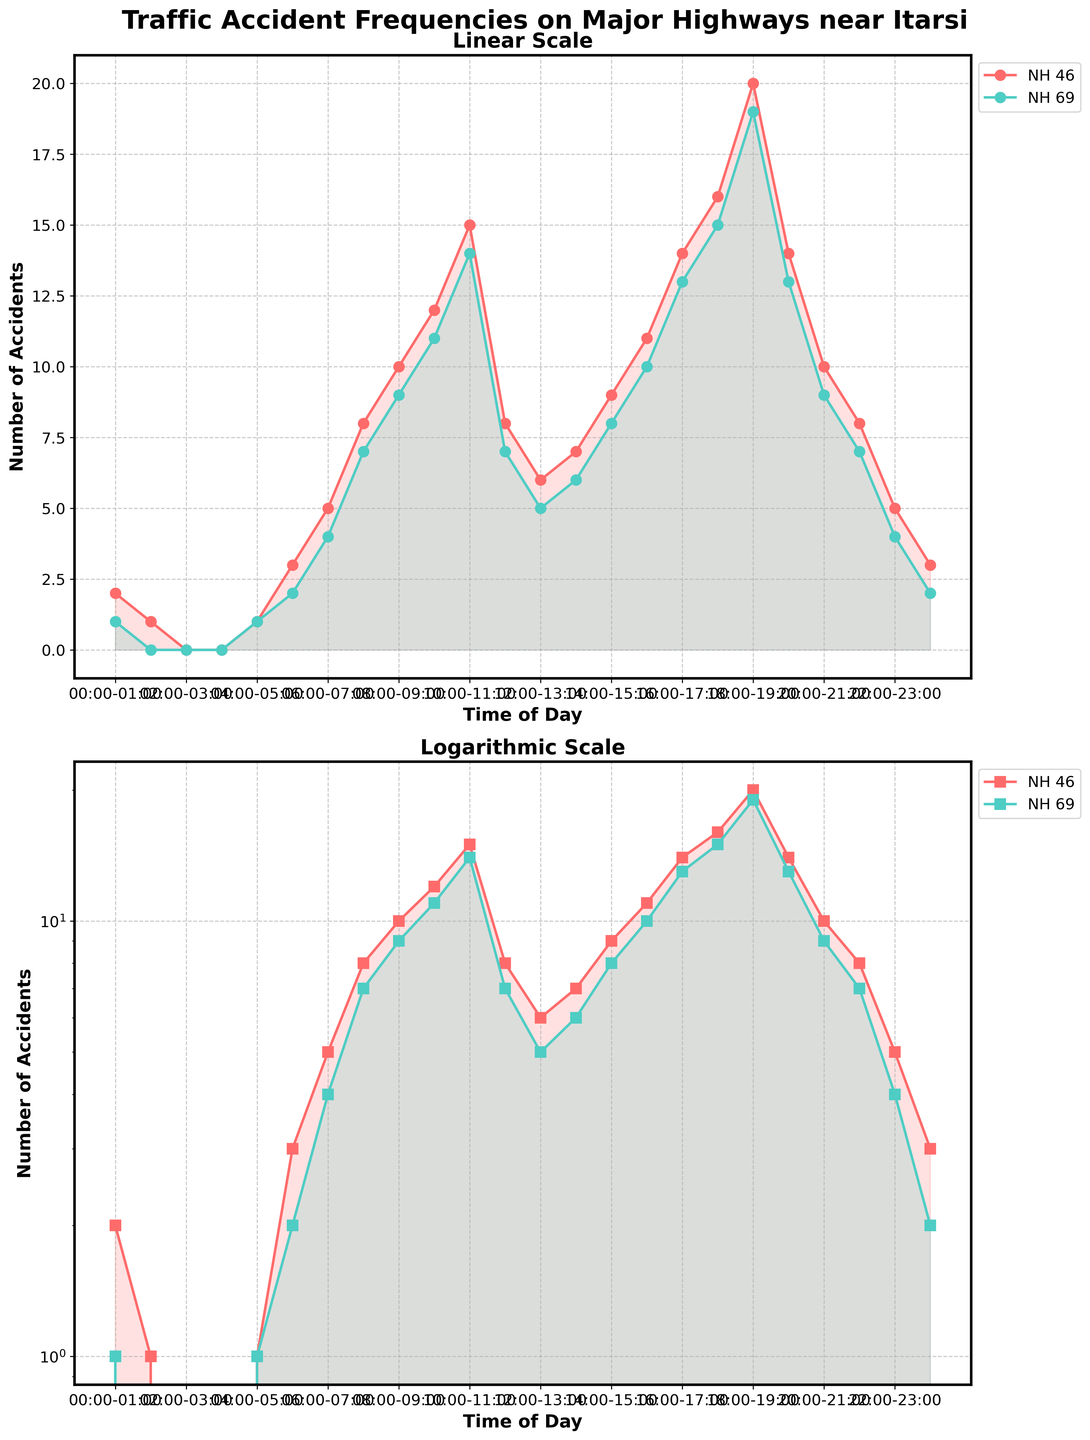What is the title of the figure? The title of the figure is located at the top and provides the main subject of the plot.
Answer: Traffic Accident Frequencies on Major Highways near Itarsi What are the highways compared in the figure? The figure compares two datasets, distinguished by labels and colors, corresponding to different highways. These are mentioned in the legend.
Answer: NH 46, NH 69 Which time of day has the highest number of accidents on NH 46? By examining the plotted lines and reading the values for each time slot on NH 46, we can identify the time slot with the highest accidents.
Answer: 18:00-19:00 Compare the number of accidents at 10:00-11:00 between NH 46 and NH 69. Which highway had more accidents? The plotted lines for both highways at the specified time slot show different accident counts. By comparing the two, we determine which has a higher value.
Answer: NH 69 Which highway shows a faster increase in accidents between 06:00 and 09:00? By following the changes in the plots for both highways between 06:00 and 09:00, we compare the slopes to determine the rate of increase.
Answer: NH 46 In the logarithmic scale subplot, which time of day has less than 5 accidents for both highways? The logarithmic scale subplot helps identify lower counts effectively, and by looking at the points and filled areas below 5 on the y-axis, we can determine the relevant time slots.
Answer: 22:00-23:00, 23:00-00:00 Which highway has fewer accidents late at night (00:00-04:00)? By comparing the plotted accident data for the specified time range in both subplots, we determine which highway has fewer accidents.
Answer: NH 69 How does the trend in accidents change after 17:00 on NH 69? Observing the plotted line for NH 69 after 17:00 helps identify any trends such as increases, decreases, or fluctuations in accident counts.
Answer: Increases & decreases What can you infer about traffic safety at different times of day from the logarithmic scale plot? The logarithmic scale plot emphasizes relative differences in accident frequency across different times of day, helping to infer patterns and periods of higher or lower risk.
Answer: Peak accident times in the evening, lower risk late at night 